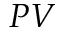<formula> <loc_0><loc_0><loc_500><loc_500>P V</formula> 